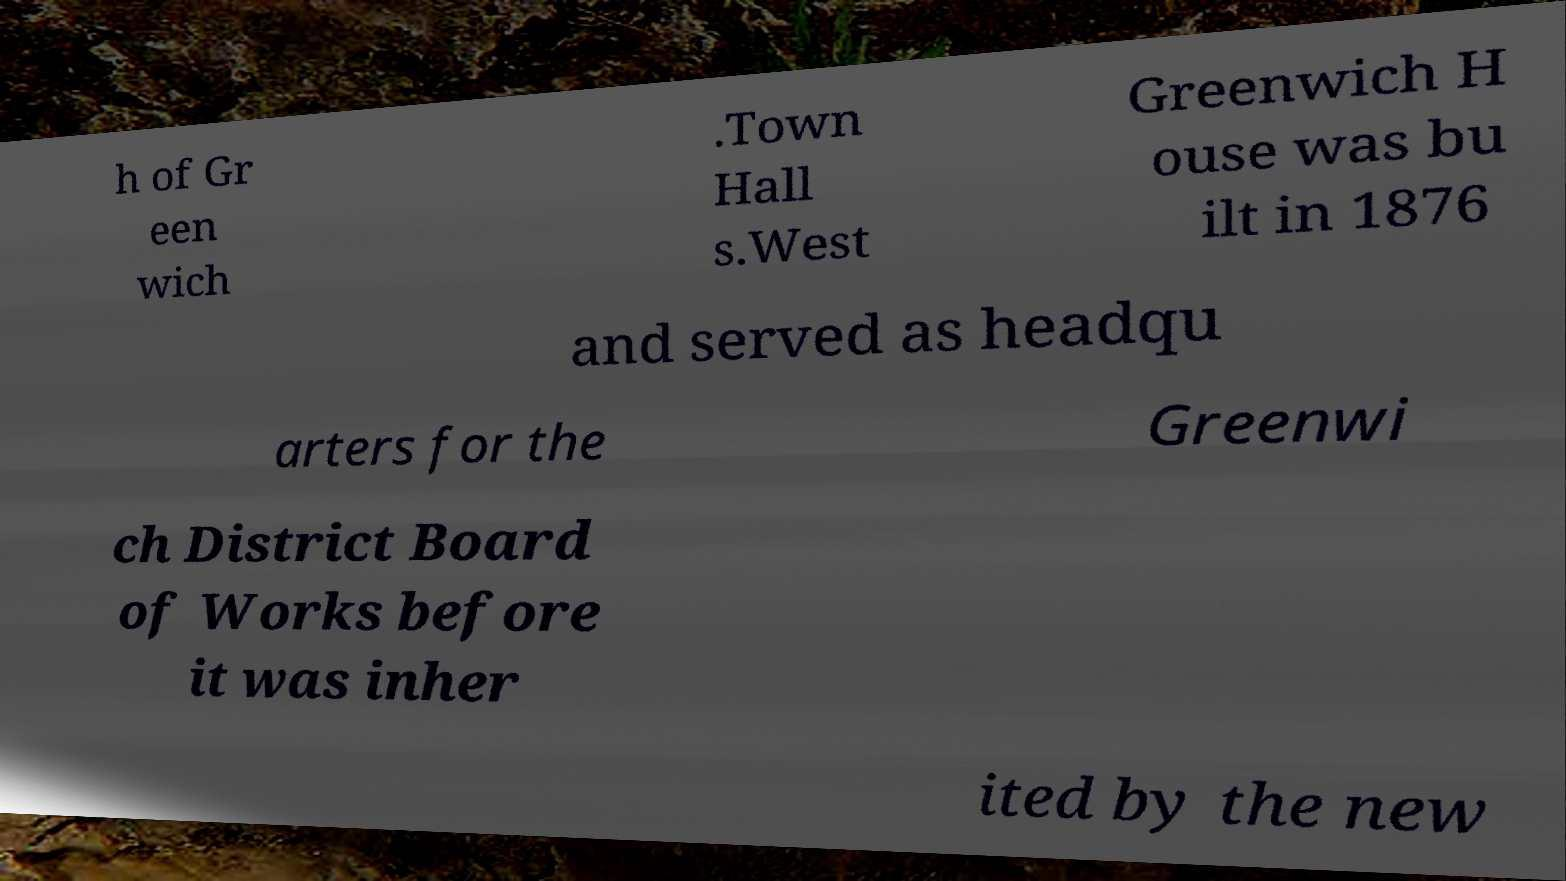What messages or text are displayed in this image? I need them in a readable, typed format. h of Gr een wich .Town Hall s.West Greenwich H ouse was bu ilt in 1876 and served as headqu arters for the Greenwi ch District Board of Works before it was inher ited by the new 